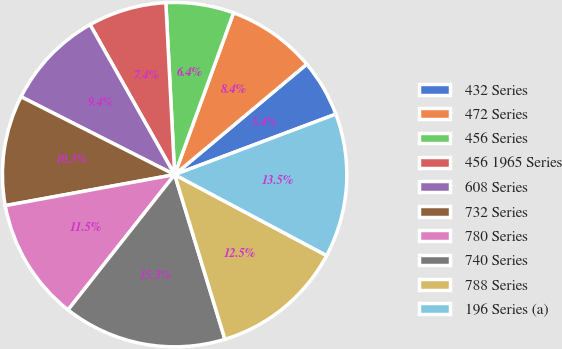<chart> <loc_0><loc_0><loc_500><loc_500><pie_chart><fcel>432 Series<fcel>472 Series<fcel>456 Series<fcel>456 1965 Series<fcel>608 Series<fcel>732 Series<fcel>780 Series<fcel>740 Series<fcel>788 Series<fcel>196 Series (a)<nl><fcel>5.37%<fcel>8.36%<fcel>6.37%<fcel>7.36%<fcel>9.36%<fcel>10.35%<fcel>11.5%<fcel>15.34%<fcel>12.5%<fcel>13.5%<nl></chart> 